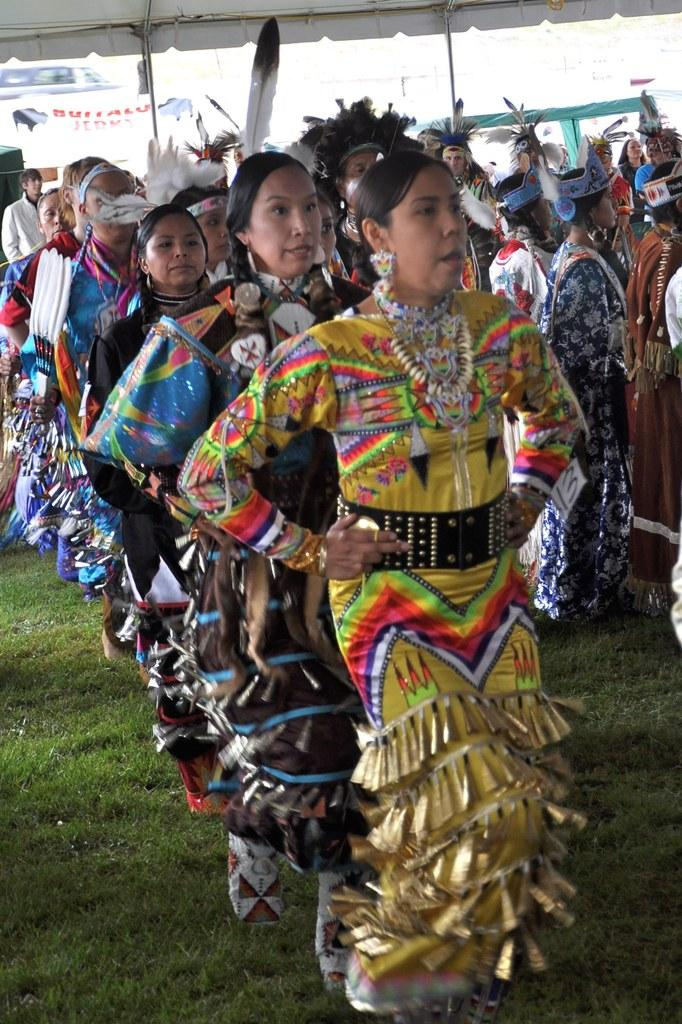How many people are in the image? There is a group of people in the image. What are some of the people in the image doing? Some people are walking, while others are standing on the grass. What structures can be seen in the image? There are poles and a tent visible in the image. What else is present in the image? Banners and a vehicle are also present in the image. What type of vegetable is being used as a prop in the image? There is no vegetable present in the image. How many sisters are visible in the image? There is no mention of sisters in the image, so it cannot be determined how many are present. 